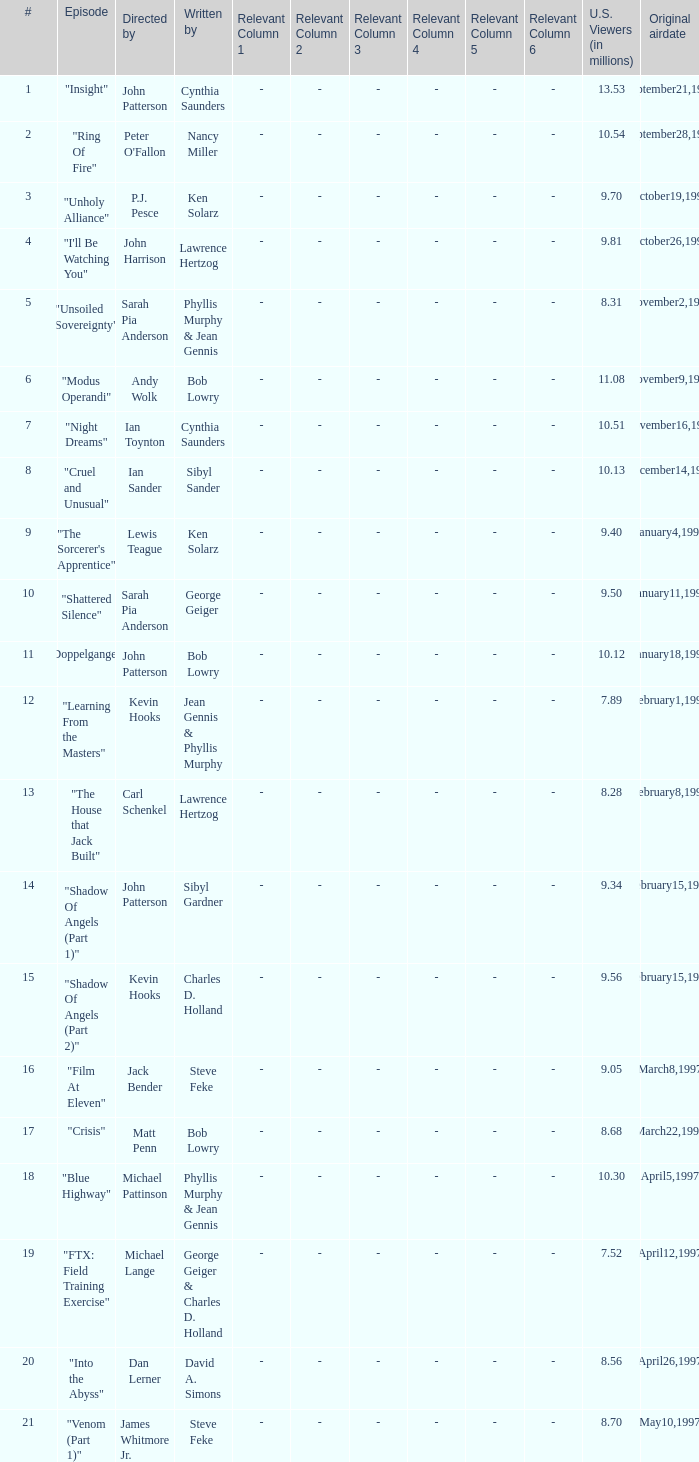What are the titles of episodes numbered 19? "FTX: Field Training Exercise". 